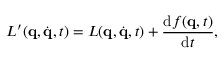<formula> <loc_0><loc_0><loc_500><loc_500>L ^ { \prime } ( q , { \dot { q } } , t ) = L ( q , { \dot { q } } , t ) + { \frac { d f ( q , t ) } { d t } } ,</formula> 